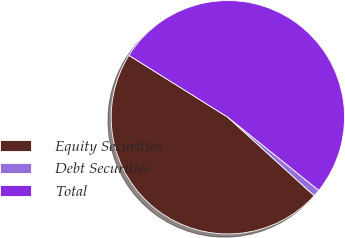<chart> <loc_0><loc_0><loc_500><loc_500><pie_chart><fcel>Equity Securities<fcel>Debt Securities<fcel>Total<nl><fcel>47.16%<fcel>0.96%<fcel>51.88%<nl></chart> 